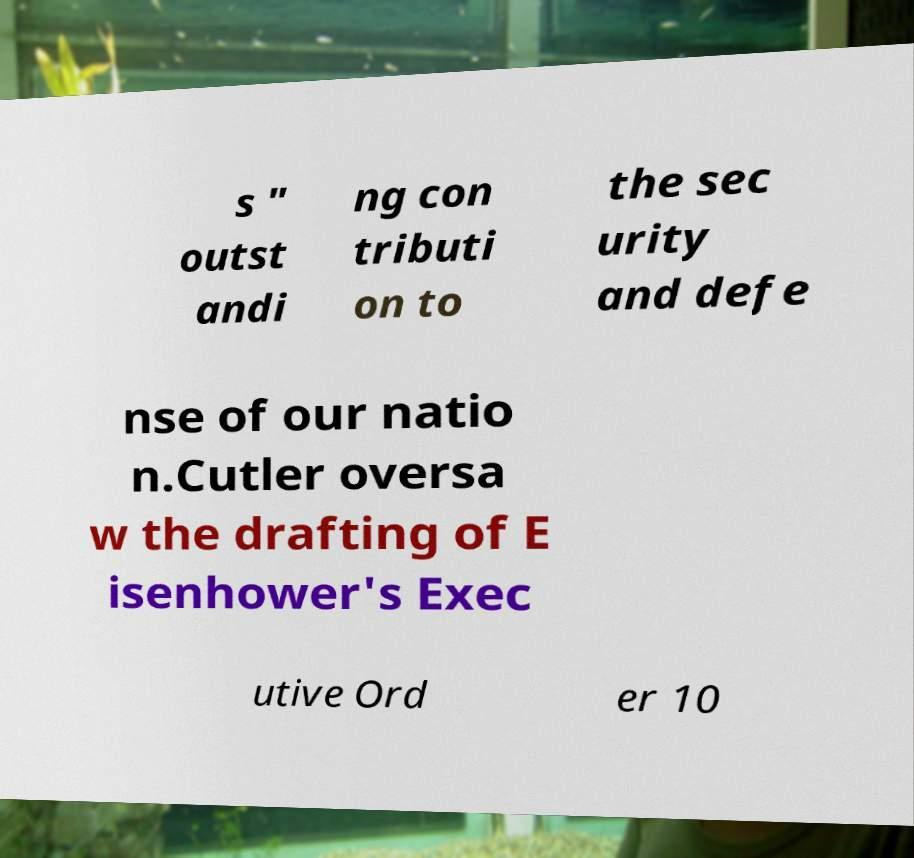What messages or text are displayed in this image? I need them in a readable, typed format. s " outst andi ng con tributi on to the sec urity and defe nse of our natio n.Cutler oversa w the drafting of E isenhower's Exec utive Ord er 10 